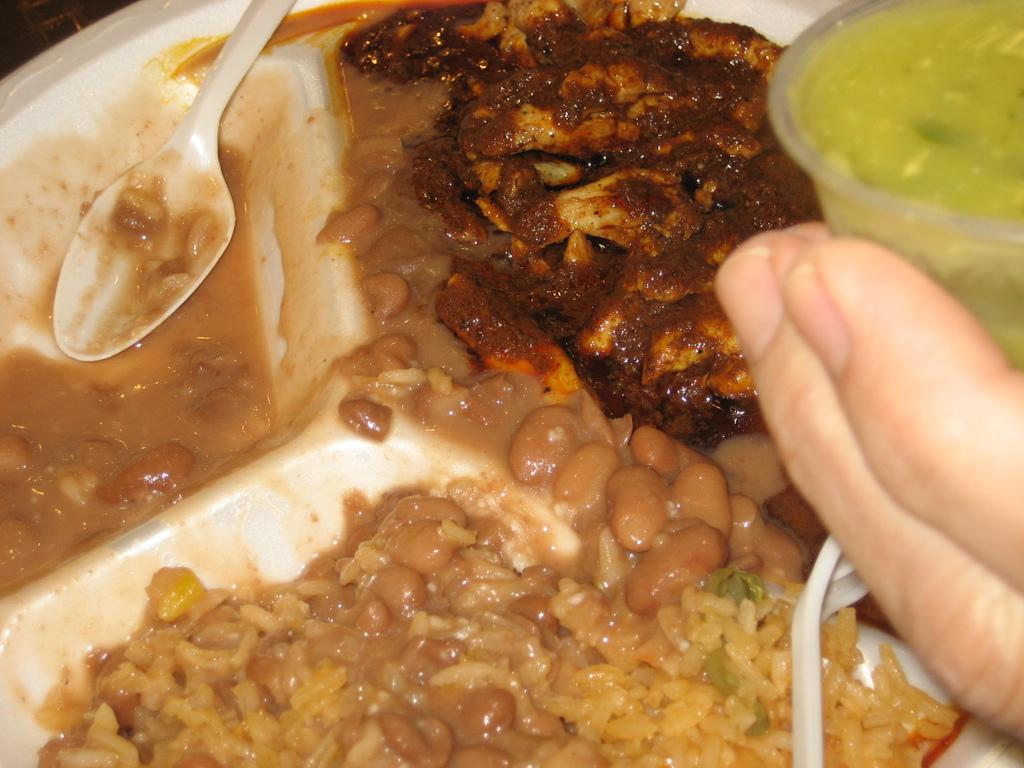What is located in the center of the image? There is a plate in the center of the image. What is on the plate? The plate contains food items. Can you describe anything else visible on the right side of the image? There is a hand on the right side of the image. What type of plantation can be seen in the background of the image? There is no plantation visible in the image; it only contains a plate with food items and a hand on the right side. 